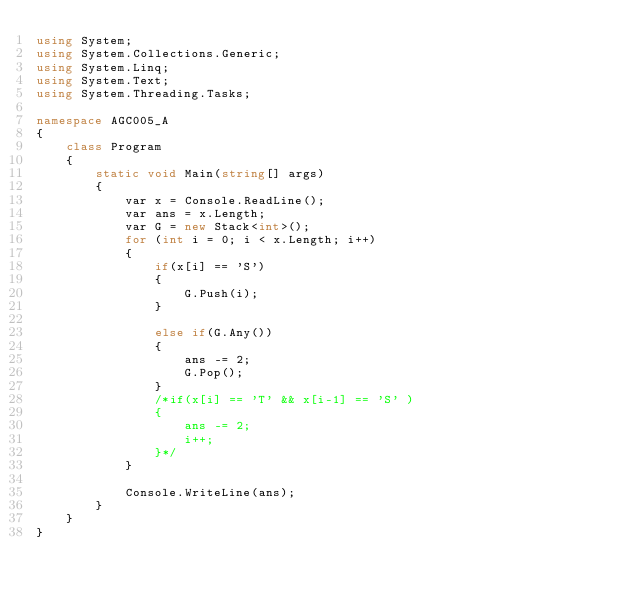<code> <loc_0><loc_0><loc_500><loc_500><_C#_>using System;
using System.Collections.Generic;
using System.Linq;
using System.Text;
using System.Threading.Tasks;

namespace AGC005_A
{
    class Program
    {
        static void Main(string[] args)
        {
            var x = Console.ReadLine();
            var ans = x.Length;
            var G = new Stack<int>();
            for (int i = 0; i < x.Length; i++)
            {
                if(x[i] == 'S')
                {
                    G.Push(i);
                }

                else if(G.Any())
                {
                    ans -= 2;
                    G.Pop();
                }
                /*if(x[i] == 'T' && x[i-1] == 'S' )
                {
                    ans -= 2;
                    i++;
                }*/
            }

            Console.WriteLine(ans);
        }
    }
}
</code> 